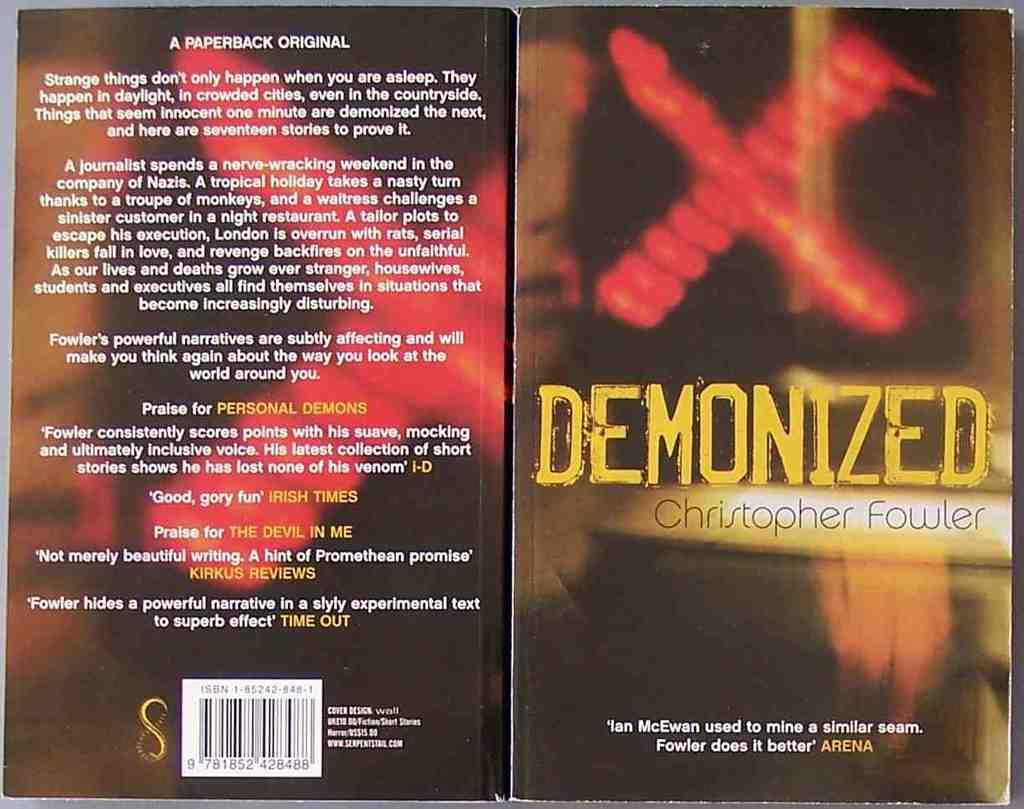<image>
Give a short and clear explanation of the subsequent image. Demonized by Christopher Fowler is open to show both covers. 